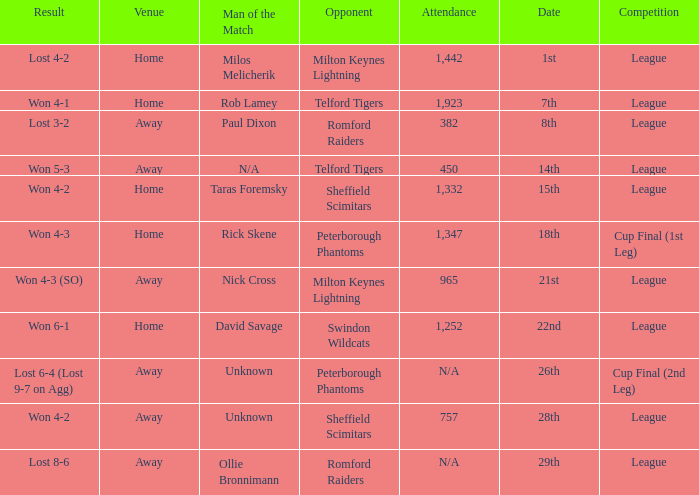On what date was the venue Away and the result was lost 6-4 (lost 9-7 on agg)? 26th. 